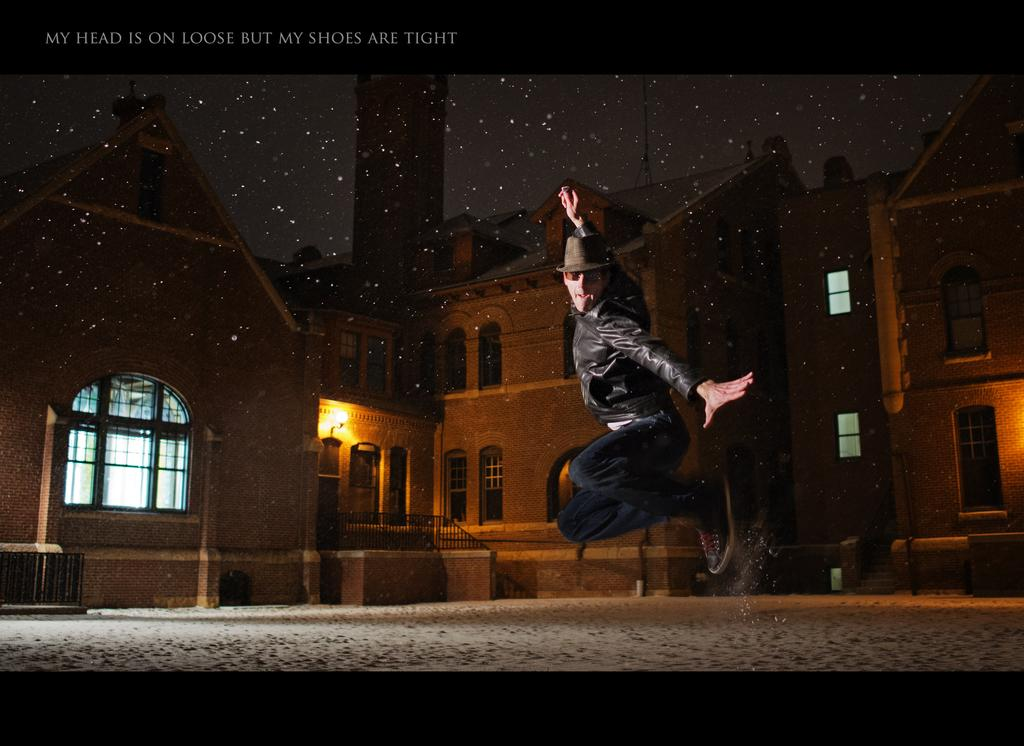What is the main subject of the image? There is a person in the air in the image. What can be seen in the background of the image? There are buildings and some objects in the background of the image. Is there any text visible in the image? Yes, there is text visible in the top left corner of the image. How does the person in the image maintain their grip on the stomach? There is no mention of a stomach or grip in the image; the person is simply in the air. 